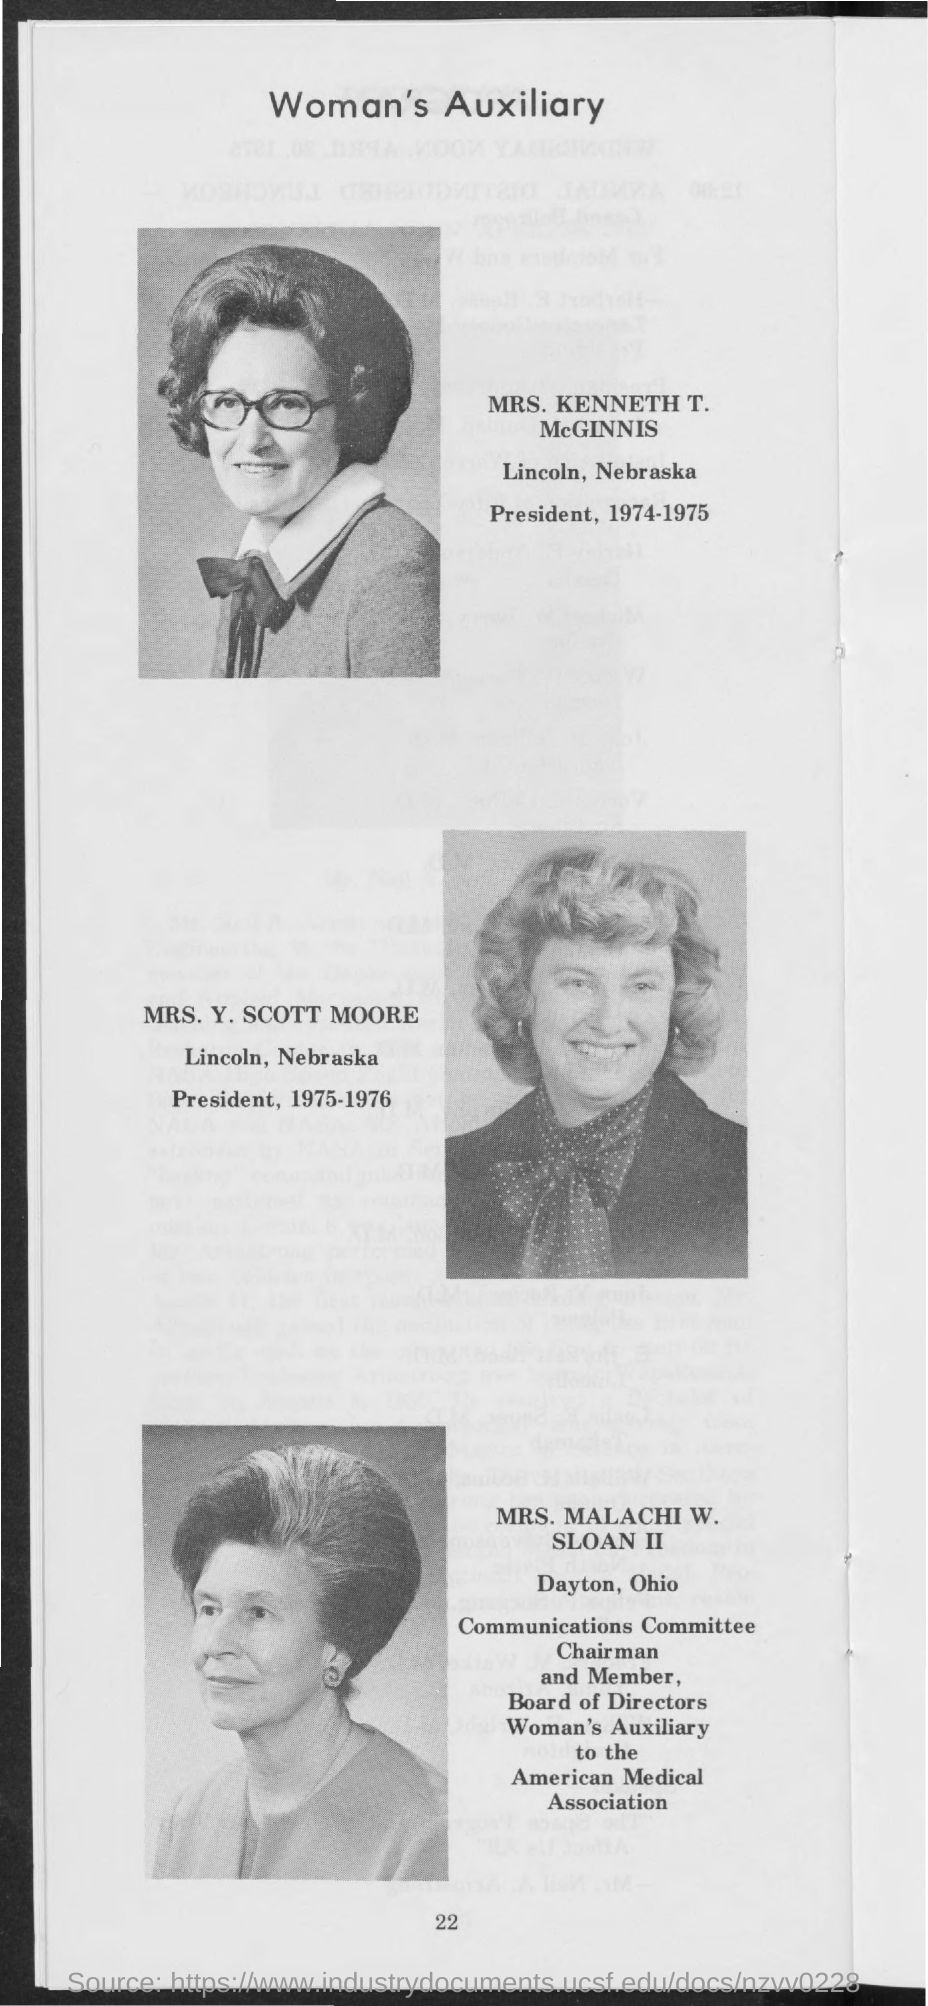Who is the President of Lincoln, Nebraska during the year 1974-1975?
Your answer should be very brief. MRS. KENNETH T. McGINNIS. Who is the President of Lincoln, Nebraska during the year 1975-1976?
Offer a terse response. MRS. Y. SCOTT MOORE. 